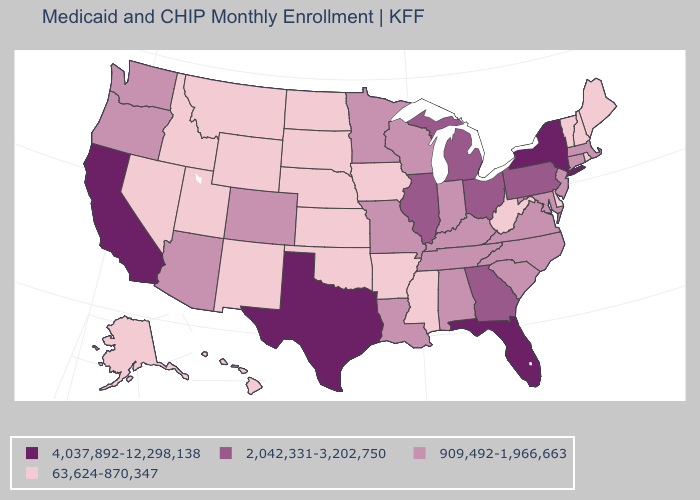Does Maine have a higher value than Illinois?
Answer briefly. No. Which states have the lowest value in the USA?
Give a very brief answer. Alaska, Arkansas, Delaware, Hawaii, Idaho, Iowa, Kansas, Maine, Mississippi, Montana, Nebraska, Nevada, New Hampshire, New Mexico, North Dakota, Oklahoma, Rhode Island, South Dakota, Utah, Vermont, West Virginia, Wyoming. Name the states that have a value in the range 909,492-1,966,663?
Give a very brief answer. Alabama, Arizona, Colorado, Connecticut, Indiana, Kentucky, Louisiana, Maryland, Massachusetts, Minnesota, Missouri, New Jersey, North Carolina, Oregon, South Carolina, Tennessee, Virginia, Washington, Wisconsin. What is the value of North Carolina?
Quick response, please. 909,492-1,966,663. Which states have the lowest value in the MidWest?
Give a very brief answer. Iowa, Kansas, Nebraska, North Dakota, South Dakota. What is the lowest value in states that border Georgia?
Quick response, please. 909,492-1,966,663. Name the states that have a value in the range 909,492-1,966,663?
Write a very short answer. Alabama, Arizona, Colorado, Connecticut, Indiana, Kentucky, Louisiana, Maryland, Massachusetts, Minnesota, Missouri, New Jersey, North Carolina, Oregon, South Carolina, Tennessee, Virginia, Washington, Wisconsin. What is the value of New Hampshire?
Short answer required. 63,624-870,347. Does Colorado have a higher value than Utah?
Give a very brief answer. Yes. Among the states that border Arkansas , does Texas have the lowest value?
Answer briefly. No. Does New Mexico have the same value as Mississippi?
Keep it brief. Yes. Does Arizona have the highest value in the USA?
Answer briefly. No. What is the lowest value in the South?
Short answer required. 63,624-870,347. Does Florida have the highest value in the USA?
Concise answer only. Yes. What is the lowest value in the USA?
Quick response, please. 63,624-870,347. 